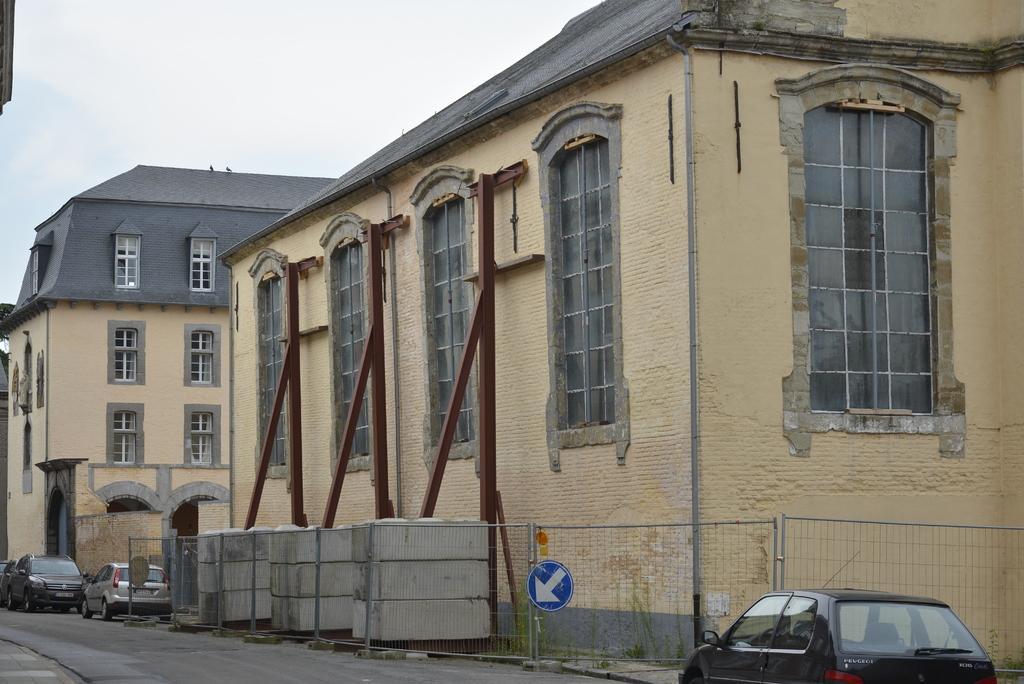How would you summarize this image in a sentence or two? In this image I can see few buildings,windows,vehicles,net fencing,signboards and iron poles. The sky is in white color. 